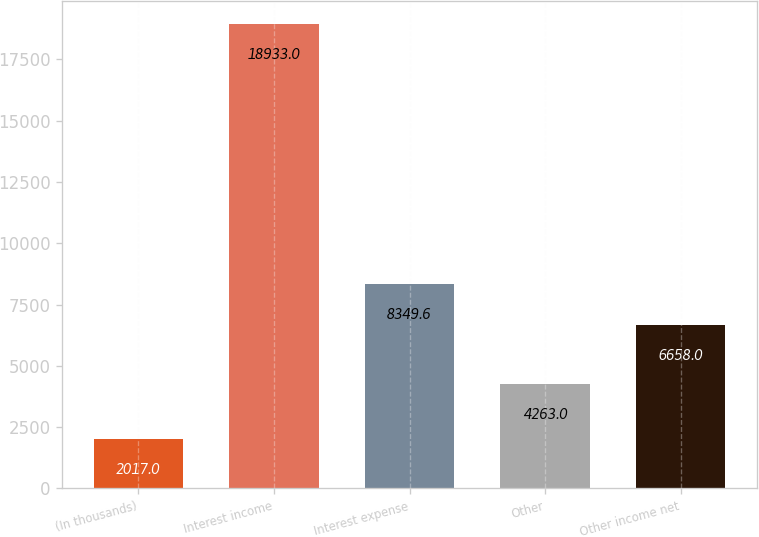Convert chart. <chart><loc_0><loc_0><loc_500><loc_500><bar_chart><fcel>(In thousands)<fcel>Interest income<fcel>Interest expense<fcel>Other<fcel>Other income net<nl><fcel>2017<fcel>18933<fcel>8349.6<fcel>4263<fcel>6658<nl></chart> 